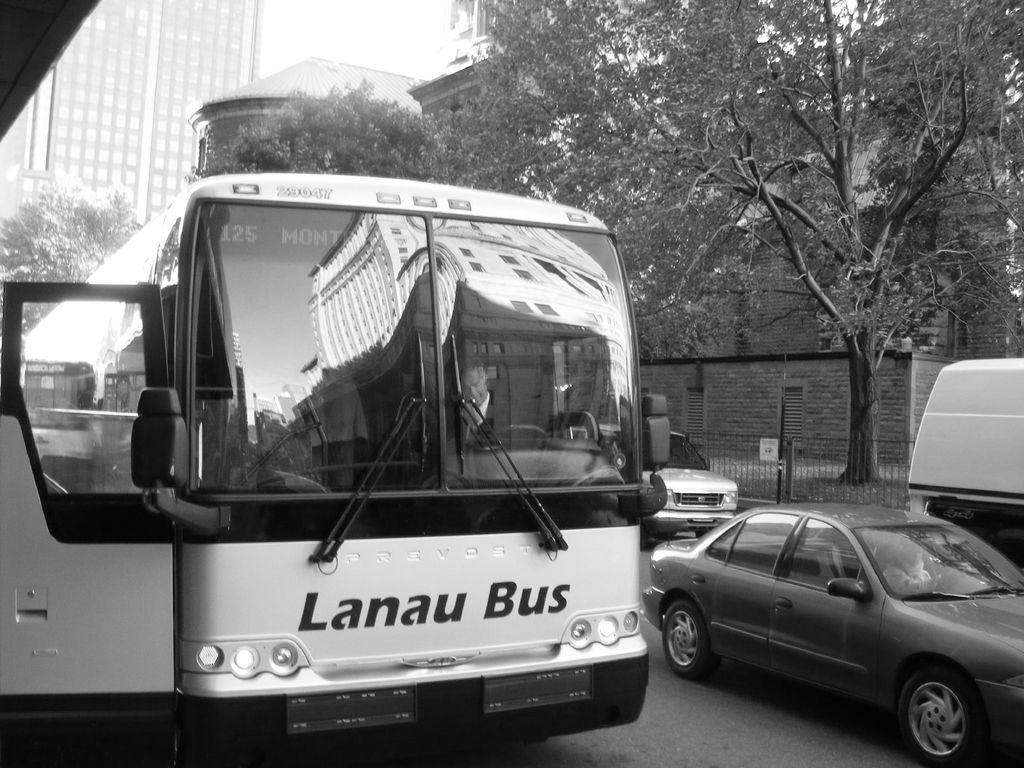What type of vehicle is the main subject in the image? There is a bus in the image. What other types of vehicles can be seen in the image? There are cars, vans, and other vehicles in the image. What is visible in the background of the image? There is a building, trees, a wall, and fencing in the background of the image. What part of the natural environment is visible in the image? The sky is visible at the top of the image. What time is it in the image? The image does not provide any information about the time. How many toes can be seen on the bus in the image? There are no toes visible in the image, as it features vehicles and a background setting. 